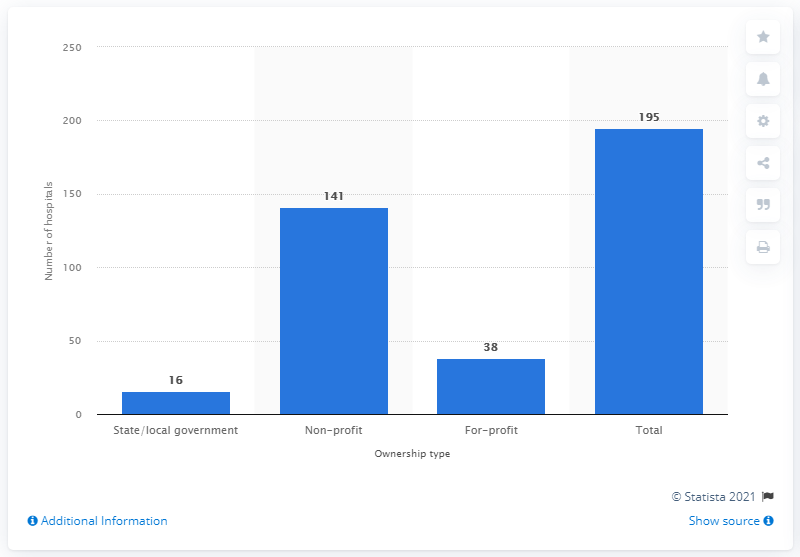Give some essential details in this illustration. In 2019, there were 16 hospitals in Ohio that were owned by the state or the local government. 